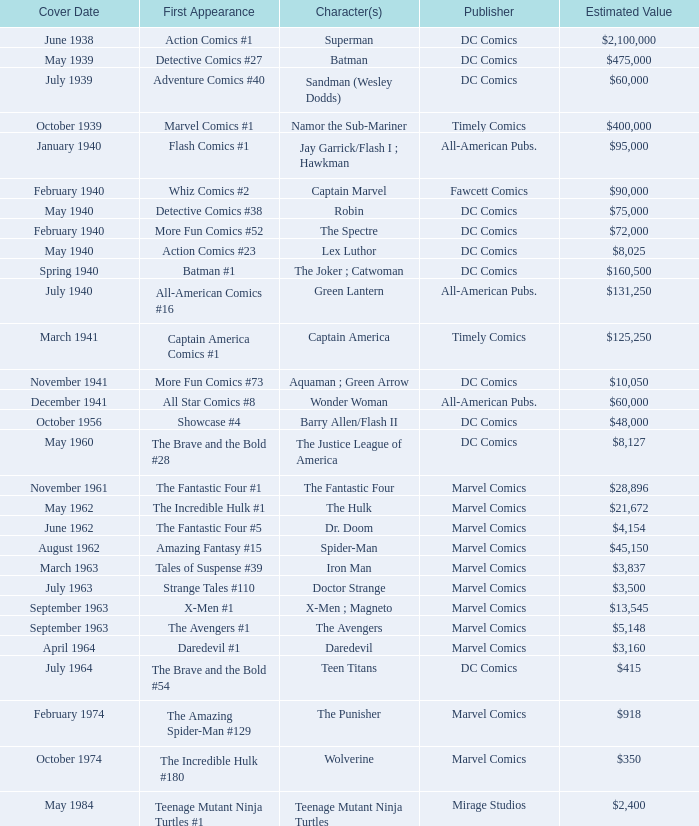What is Action Comics #1's estimated value? $2,100,000. 